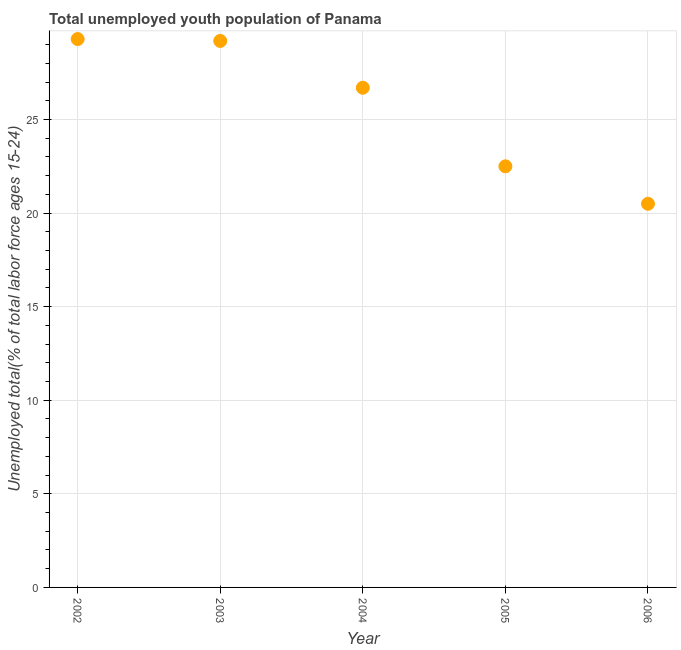What is the unemployed youth in 2006?
Give a very brief answer. 20.5. Across all years, what is the maximum unemployed youth?
Offer a terse response. 29.3. In which year was the unemployed youth maximum?
Your response must be concise. 2002. What is the sum of the unemployed youth?
Your answer should be compact. 128.2. What is the difference between the unemployed youth in 2002 and 2004?
Ensure brevity in your answer.  2.6. What is the average unemployed youth per year?
Ensure brevity in your answer.  25.64. What is the median unemployed youth?
Offer a terse response. 26.7. Do a majority of the years between 2003 and 2002 (inclusive) have unemployed youth greater than 12 %?
Offer a terse response. No. What is the ratio of the unemployed youth in 2003 to that in 2006?
Your response must be concise. 1.42. What is the difference between the highest and the second highest unemployed youth?
Your answer should be very brief. 0.1. Is the sum of the unemployed youth in 2003 and 2004 greater than the maximum unemployed youth across all years?
Provide a short and direct response. Yes. What is the difference between the highest and the lowest unemployed youth?
Provide a succinct answer. 8.8. In how many years, is the unemployed youth greater than the average unemployed youth taken over all years?
Offer a very short reply. 3. How many years are there in the graph?
Keep it short and to the point. 5. What is the difference between two consecutive major ticks on the Y-axis?
Provide a short and direct response. 5. Are the values on the major ticks of Y-axis written in scientific E-notation?
Keep it short and to the point. No. What is the title of the graph?
Offer a terse response. Total unemployed youth population of Panama. What is the label or title of the X-axis?
Your answer should be very brief. Year. What is the label or title of the Y-axis?
Provide a short and direct response. Unemployed total(% of total labor force ages 15-24). What is the Unemployed total(% of total labor force ages 15-24) in 2002?
Provide a succinct answer. 29.3. What is the Unemployed total(% of total labor force ages 15-24) in 2003?
Your answer should be compact. 29.2. What is the Unemployed total(% of total labor force ages 15-24) in 2004?
Your response must be concise. 26.7. What is the Unemployed total(% of total labor force ages 15-24) in 2005?
Your answer should be compact. 22.5. What is the Unemployed total(% of total labor force ages 15-24) in 2006?
Give a very brief answer. 20.5. What is the difference between the Unemployed total(% of total labor force ages 15-24) in 2002 and 2006?
Offer a very short reply. 8.8. What is the difference between the Unemployed total(% of total labor force ages 15-24) in 2003 and 2006?
Provide a short and direct response. 8.7. What is the ratio of the Unemployed total(% of total labor force ages 15-24) in 2002 to that in 2004?
Your answer should be compact. 1.1. What is the ratio of the Unemployed total(% of total labor force ages 15-24) in 2002 to that in 2005?
Your answer should be very brief. 1.3. What is the ratio of the Unemployed total(% of total labor force ages 15-24) in 2002 to that in 2006?
Ensure brevity in your answer.  1.43. What is the ratio of the Unemployed total(% of total labor force ages 15-24) in 2003 to that in 2004?
Provide a short and direct response. 1.09. What is the ratio of the Unemployed total(% of total labor force ages 15-24) in 2003 to that in 2005?
Provide a succinct answer. 1.3. What is the ratio of the Unemployed total(% of total labor force ages 15-24) in 2003 to that in 2006?
Give a very brief answer. 1.42. What is the ratio of the Unemployed total(% of total labor force ages 15-24) in 2004 to that in 2005?
Ensure brevity in your answer.  1.19. What is the ratio of the Unemployed total(% of total labor force ages 15-24) in 2004 to that in 2006?
Offer a terse response. 1.3. What is the ratio of the Unemployed total(% of total labor force ages 15-24) in 2005 to that in 2006?
Offer a very short reply. 1.1. 